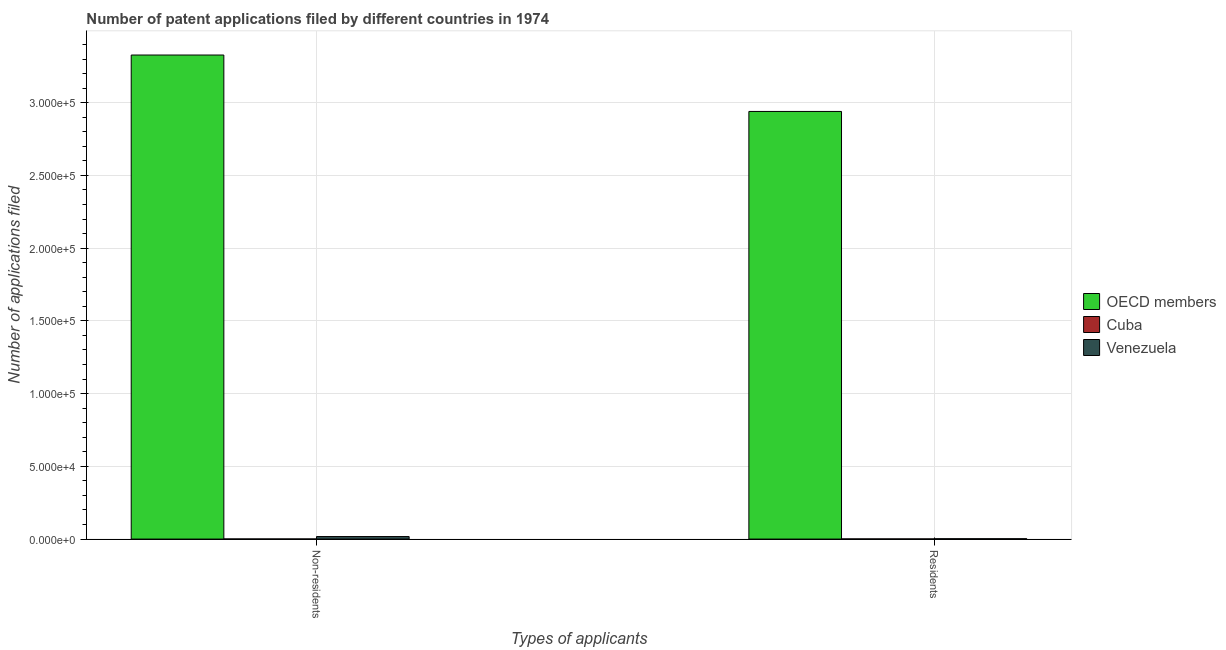How many different coloured bars are there?
Offer a terse response. 3. How many groups of bars are there?
Your answer should be very brief. 2. Are the number of bars per tick equal to the number of legend labels?
Your response must be concise. Yes. Are the number of bars on each tick of the X-axis equal?
Keep it short and to the point. Yes. How many bars are there on the 1st tick from the left?
Keep it short and to the point. 3. What is the label of the 1st group of bars from the left?
Ensure brevity in your answer.  Non-residents. What is the number of patent applications by non residents in OECD members?
Your response must be concise. 3.33e+05. Across all countries, what is the maximum number of patent applications by non residents?
Provide a short and direct response. 3.33e+05. Across all countries, what is the minimum number of patent applications by residents?
Offer a terse response. 97. In which country was the number of patent applications by residents minimum?
Offer a terse response. Cuba. What is the total number of patent applications by residents in the graph?
Make the answer very short. 2.94e+05. What is the difference between the number of patent applications by non residents in Venezuela and that in Cuba?
Keep it short and to the point. 1667. What is the difference between the number of patent applications by non residents in OECD members and the number of patent applications by residents in Cuba?
Your answer should be compact. 3.33e+05. What is the average number of patent applications by non residents per country?
Give a very brief answer. 1.12e+05. What is the difference between the number of patent applications by non residents and number of patent applications by residents in OECD members?
Provide a short and direct response. 3.88e+04. What is the ratio of the number of patent applications by residents in Venezuela to that in OECD members?
Your answer should be compact. 0. What does the 3rd bar from the left in Non-residents represents?
Your answer should be very brief. Venezuela. What does the 1st bar from the right in Non-residents represents?
Ensure brevity in your answer.  Venezuela. How many countries are there in the graph?
Your answer should be compact. 3. Does the graph contain any zero values?
Ensure brevity in your answer.  No. Does the graph contain grids?
Give a very brief answer. Yes. How many legend labels are there?
Your response must be concise. 3. How are the legend labels stacked?
Offer a very short reply. Vertical. What is the title of the graph?
Your answer should be very brief. Number of patent applications filed by different countries in 1974. Does "Tunisia" appear as one of the legend labels in the graph?
Give a very brief answer. No. What is the label or title of the X-axis?
Your answer should be very brief. Types of applicants. What is the label or title of the Y-axis?
Provide a succinct answer. Number of applications filed. What is the Number of applications filed in OECD members in Non-residents?
Keep it short and to the point. 3.33e+05. What is the Number of applications filed in Cuba in Non-residents?
Offer a terse response. 70. What is the Number of applications filed of Venezuela in Non-residents?
Offer a very short reply. 1737. What is the Number of applications filed in OECD members in Residents?
Give a very brief answer. 2.94e+05. What is the Number of applications filed of Cuba in Residents?
Offer a terse response. 97. What is the Number of applications filed in Venezuela in Residents?
Offer a very short reply. 241. Across all Types of applicants, what is the maximum Number of applications filed in OECD members?
Ensure brevity in your answer.  3.33e+05. Across all Types of applicants, what is the maximum Number of applications filed in Cuba?
Offer a terse response. 97. Across all Types of applicants, what is the maximum Number of applications filed of Venezuela?
Your response must be concise. 1737. Across all Types of applicants, what is the minimum Number of applications filed in OECD members?
Give a very brief answer. 2.94e+05. Across all Types of applicants, what is the minimum Number of applications filed in Venezuela?
Give a very brief answer. 241. What is the total Number of applications filed in OECD members in the graph?
Ensure brevity in your answer.  6.27e+05. What is the total Number of applications filed in Cuba in the graph?
Make the answer very short. 167. What is the total Number of applications filed of Venezuela in the graph?
Your answer should be compact. 1978. What is the difference between the Number of applications filed of OECD members in Non-residents and that in Residents?
Give a very brief answer. 3.88e+04. What is the difference between the Number of applications filed of Cuba in Non-residents and that in Residents?
Ensure brevity in your answer.  -27. What is the difference between the Number of applications filed in Venezuela in Non-residents and that in Residents?
Offer a terse response. 1496. What is the difference between the Number of applications filed of OECD members in Non-residents and the Number of applications filed of Cuba in Residents?
Your answer should be compact. 3.33e+05. What is the difference between the Number of applications filed of OECD members in Non-residents and the Number of applications filed of Venezuela in Residents?
Provide a succinct answer. 3.33e+05. What is the difference between the Number of applications filed in Cuba in Non-residents and the Number of applications filed in Venezuela in Residents?
Keep it short and to the point. -171. What is the average Number of applications filed in OECD members per Types of applicants?
Your answer should be compact. 3.13e+05. What is the average Number of applications filed of Cuba per Types of applicants?
Offer a terse response. 83.5. What is the average Number of applications filed in Venezuela per Types of applicants?
Your response must be concise. 989. What is the difference between the Number of applications filed of OECD members and Number of applications filed of Cuba in Non-residents?
Provide a short and direct response. 3.33e+05. What is the difference between the Number of applications filed of OECD members and Number of applications filed of Venezuela in Non-residents?
Provide a short and direct response. 3.31e+05. What is the difference between the Number of applications filed in Cuba and Number of applications filed in Venezuela in Non-residents?
Your answer should be very brief. -1667. What is the difference between the Number of applications filed in OECD members and Number of applications filed in Cuba in Residents?
Your answer should be compact. 2.94e+05. What is the difference between the Number of applications filed in OECD members and Number of applications filed in Venezuela in Residents?
Offer a very short reply. 2.94e+05. What is the difference between the Number of applications filed in Cuba and Number of applications filed in Venezuela in Residents?
Offer a very short reply. -144. What is the ratio of the Number of applications filed in OECD members in Non-residents to that in Residents?
Keep it short and to the point. 1.13. What is the ratio of the Number of applications filed of Cuba in Non-residents to that in Residents?
Your answer should be very brief. 0.72. What is the ratio of the Number of applications filed of Venezuela in Non-residents to that in Residents?
Your response must be concise. 7.21. What is the difference between the highest and the second highest Number of applications filed in OECD members?
Your answer should be compact. 3.88e+04. What is the difference between the highest and the second highest Number of applications filed of Venezuela?
Make the answer very short. 1496. What is the difference between the highest and the lowest Number of applications filed of OECD members?
Your response must be concise. 3.88e+04. What is the difference between the highest and the lowest Number of applications filed in Venezuela?
Provide a succinct answer. 1496. 